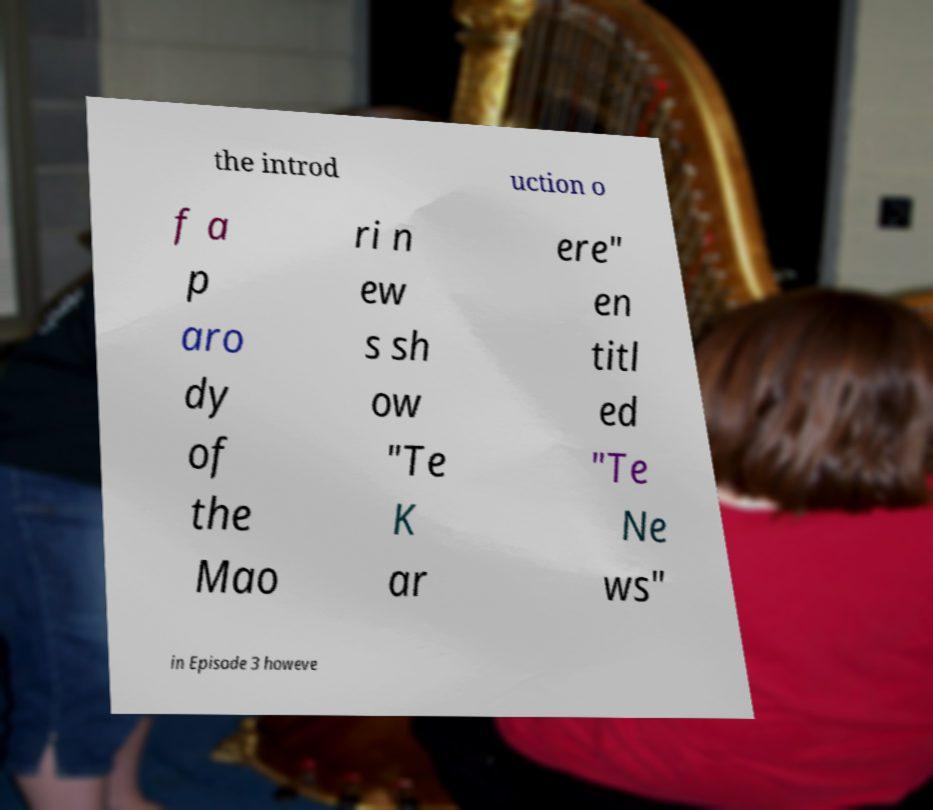Please identify and transcribe the text found in this image. the introd uction o f a p aro dy of the Mao ri n ew s sh ow "Te K ar ere" en titl ed "Te Ne ws" in Episode 3 howeve 